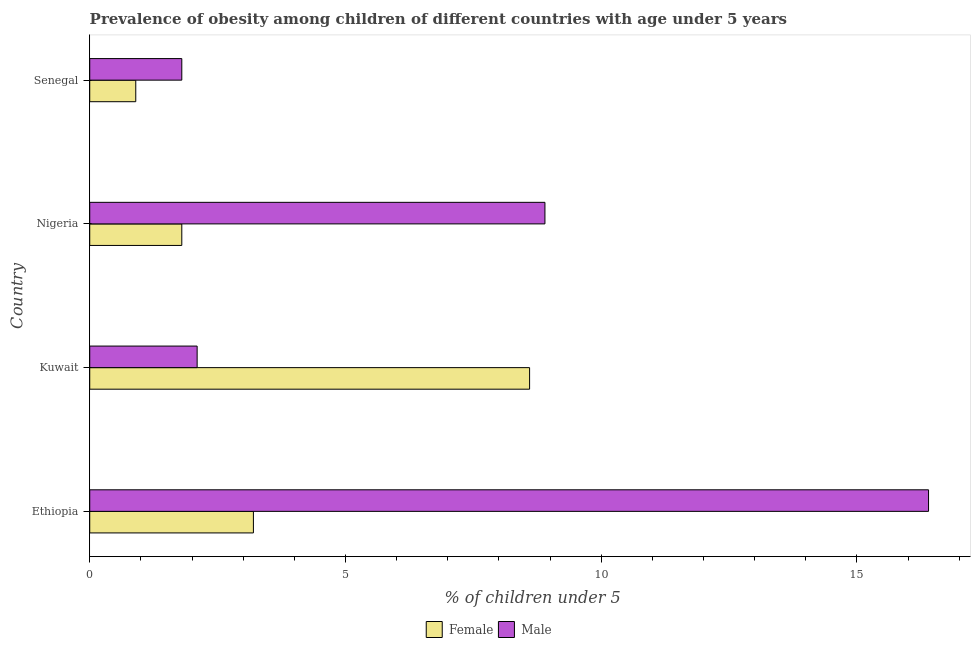How many different coloured bars are there?
Keep it short and to the point. 2. Are the number of bars on each tick of the Y-axis equal?
Make the answer very short. Yes. How many bars are there on the 4th tick from the top?
Ensure brevity in your answer.  2. What is the label of the 2nd group of bars from the top?
Offer a terse response. Nigeria. In how many cases, is the number of bars for a given country not equal to the number of legend labels?
Offer a very short reply. 0. What is the percentage of obese male children in Kuwait?
Ensure brevity in your answer.  2.1. Across all countries, what is the maximum percentage of obese female children?
Provide a succinct answer. 8.6. Across all countries, what is the minimum percentage of obese female children?
Ensure brevity in your answer.  0.9. In which country was the percentage of obese female children maximum?
Offer a terse response. Kuwait. In which country was the percentage of obese male children minimum?
Offer a very short reply. Senegal. What is the total percentage of obese male children in the graph?
Provide a succinct answer. 29.2. What is the difference between the percentage of obese male children in Kuwait and the percentage of obese female children in Nigeria?
Your response must be concise. 0.3. What is the average percentage of obese female children per country?
Give a very brief answer. 3.62. What is the ratio of the percentage of obese female children in Ethiopia to that in Nigeria?
Offer a terse response. 1.78. Is the percentage of obese male children in Ethiopia less than that in Nigeria?
Offer a terse response. No. What is the difference between the highest and the second highest percentage of obese female children?
Offer a very short reply. 5.4. In how many countries, is the percentage of obese female children greater than the average percentage of obese female children taken over all countries?
Your answer should be very brief. 1. What does the 2nd bar from the bottom in Kuwait represents?
Your answer should be very brief. Male. How many bars are there?
Your answer should be compact. 8. How many countries are there in the graph?
Provide a short and direct response. 4. What is the difference between two consecutive major ticks on the X-axis?
Your answer should be very brief. 5. Are the values on the major ticks of X-axis written in scientific E-notation?
Provide a succinct answer. No. Does the graph contain grids?
Give a very brief answer. No. How many legend labels are there?
Your answer should be compact. 2. What is the title of the graph?
Provide a succinct answer. Prevalence of obesity among children of different countries with age under 5 years. Does "Imports" appear as one of the legend labels in the graph?
Offer a terse response. No. What is the label or title of the X-axis?
Make the answer very short.  % of children under 5. What is the  % of children under 5 in Female in Ethiopia?
Provide a succinct answer. 3.2. What is the  % of children under 5 of Male in Ethiopia?
Provide a short and direct response. 16.4. What is the  % of children under 5 of Female in Kuwait?
Keep it short and to the point. 8.6. What is the  % of children under 5 in Male in Kuwait?
Your answer should be compact. 2.1. What is the  % of children under 5 of Female in Nigeria?
Your response must be concise. 1.8. What is the  % of children under 5 of Male in Nigeria?
Make the answer very short. 8.9. What is the  % of children under 5 in Female in Senegal?
Keep it short and to the point. 0.9. What is the  % of children under 5 of Male in Senegal?
Your response must be concise. 1.8. Across all countries, what is the maximum  % of children under 5 in Female?
Your answer should be very brief. 8.6. Across all countries, what is the maximum  % of children under 5 in Male?
Keep it short and to the point. 16.4. Across all countries, what is the minimum  % of children under 5 of Female?
Give a very brief answer. 0.9. Across all countries, what is the minimum  % of children under 5 in Male?
Your response must be concise. 1.8. What is the total  % of children under 5 in Male in the graph?
Your answer should be compact. 29.2. What is the difference between the  % of children under 5 in Female in Ethiopia and that in Kuwait?
Your answer should be very brief. -5.4. What is the difference between the  % of children under 5 of Male in Ethiopia and that in Kuwait?
Your answer should be compact. 14.3. What is the difference between the  % of children under 5 of Female in Ethiopia and that in Nigeria?
Make the answer very short. 1.4. What is the difference between the  % of children under 5 in Female in Ethiopia and that in Senegal?
Keep it short and to the point. 2.3. What is the difference between the  % of children under 5 in Male in Ethiopia and that in Senegal?
Offer a very short reply. 14.6. What is the difference between the  % of children under 5 in Female in Kuwait and that in Nigeria?
Provide a succinct answer. 6.8. What is the difference between the  % of children under 5 of Male in Kuwait and that in Nigeria?
Make the answer very short. -6.8. What is the difference between the  % of children under 5 of Male in Kuwait and that in Senegal?
Provide a succinct answer. 0.3. What is the difference between the  % of children under 5 in Female in Nigeria and that in Senegal?
Ensure brevity in your answer.  0.9. What is the difference between the  % of children under 5 in Male in Nigeria and that in Senegal?
Keep it short and to the point. 7.1. What is the difference between the  % of children under 5 in Female in Kuwait and the  % of children under 5 in Male in Senegal?
Provide a succinct answer. 6.8. What is the average  % of children under 5 of Female per country?
Offer a terse response. 3.62. What is the difference between the  % of children under 5 of Female and  % of children under 5 of Male in Ethiopia?
Provide a succinct answer. -13.2. What is the difference between the  % of children under 5 of Female and  % of children under 5 of Male in Senegal?
Provide a short and direct response. -0.9. What is the ratio of the  % of children under 5 in Female in Ethiopia to that in Kuwait?
Give a very brief answer. 0.37. What is the ratio of the  % of children under 5 of Male in Ethiopia to that in Kuwait?
Your answer should be very brief. 7.81. What is the ratio of the  % of children under 5 of Female in Ethiopia to that in Nigeria?
Provide a succinct answer. 1.78. What is the ratio of the  % of children under 5 of Male in Ethiopia to that in Nigeria?
Provide a succinct answer. 1.84. What is the ratio of the  % of children under 5 in Female in Ethiopia to that in Senegal?
Your answer should be compact. 3.56. What is the ratio of the  % of children under 5 of Male in Ethiopia to that in Senegal?
Your answer should be very brief. 9.11. What is the ratio of the  % of children under 5 in Female in Kuwait to that in Nigeria?
Your answer should be very brief. 4.78. What is the ratio of the  % of children under 5 in Male in Kuwait to that in Nigeria?
Ensure brevity in your answer.  0.24. What is the ratio of the  % of children under 5 in Female in Kuwait to that in Senegal?
Your answer should be very brief. 9.56. What is the ratio of the  % of children under 5 in Female in Nigeria to that in Senegal?
Provide a short and direct response. 2. What is the ratio of the  % of children under 5 of Male in Nigeria to that in Senegal?
Make the answer very short. 4.94. What is the difference between the highest and the second highest  % of children under 5 of Male?
Make the answer very short. 7.5. What is the difference between the highest and the lowest  % of children under 5 in Female?
Your response must be concise. 7.7. What is the difference between the highest and the lowest  % of children under 5 in Male?
Your answer should be very brief. 14.6. 